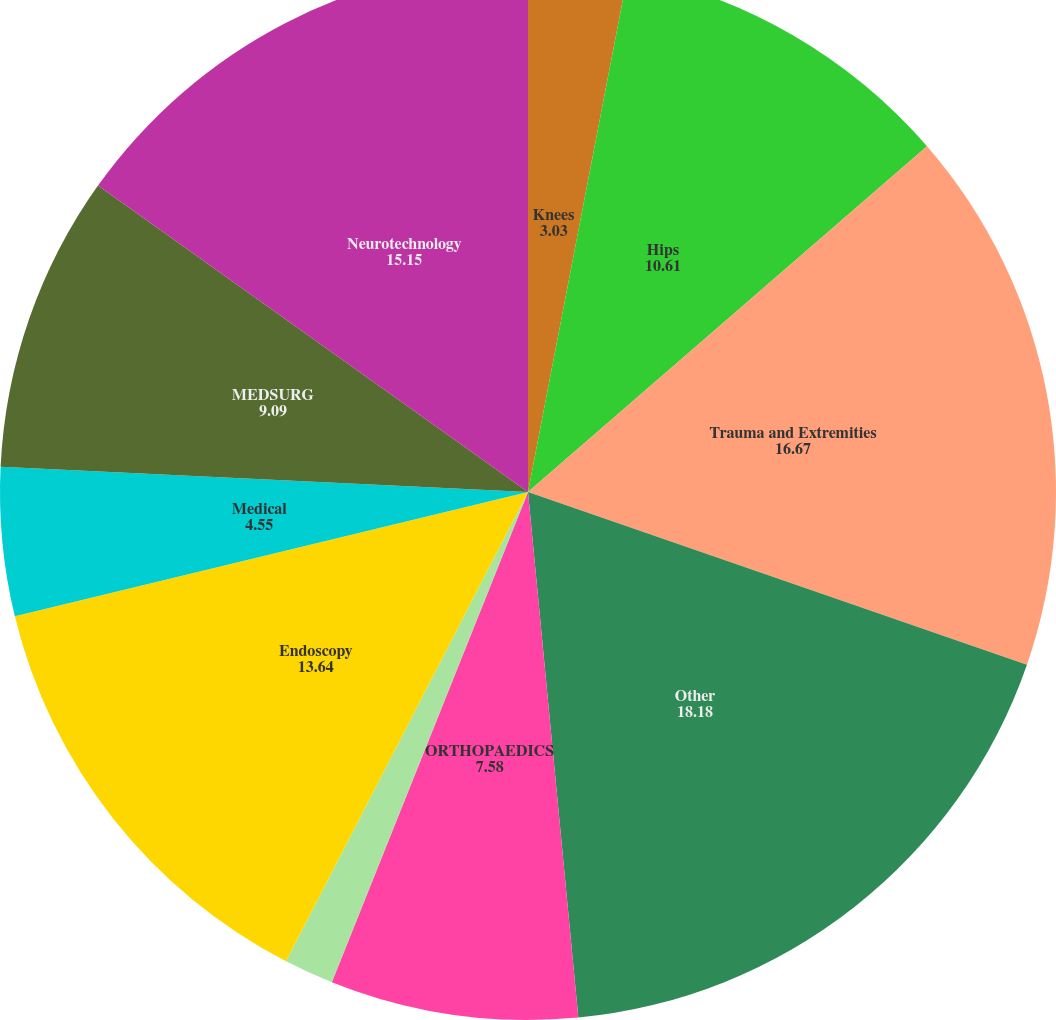Convert chart to OTSL. <chart><loc_0><loc_0><loc_500><loc_500><pie_chart><fcel>Knees<fcel>Hips<fcel>Trauma and Extremities<fcel>Other<fcel>ORTHOPAEDICS<fcel>Instruments<fcel>Endoscopy<fcel>Medical<fcel>MEDSURG<fcel>Neurotechnology<nl><fcel>3.03%<fcel>10.61%<fcel>16.67%<fcel>18.18%<fcel>7.58%<fcel>1.52%<fcel>13.64%<fcel>4.55%<fcel>9.09%<fcel>15.15%<nl></chart> 